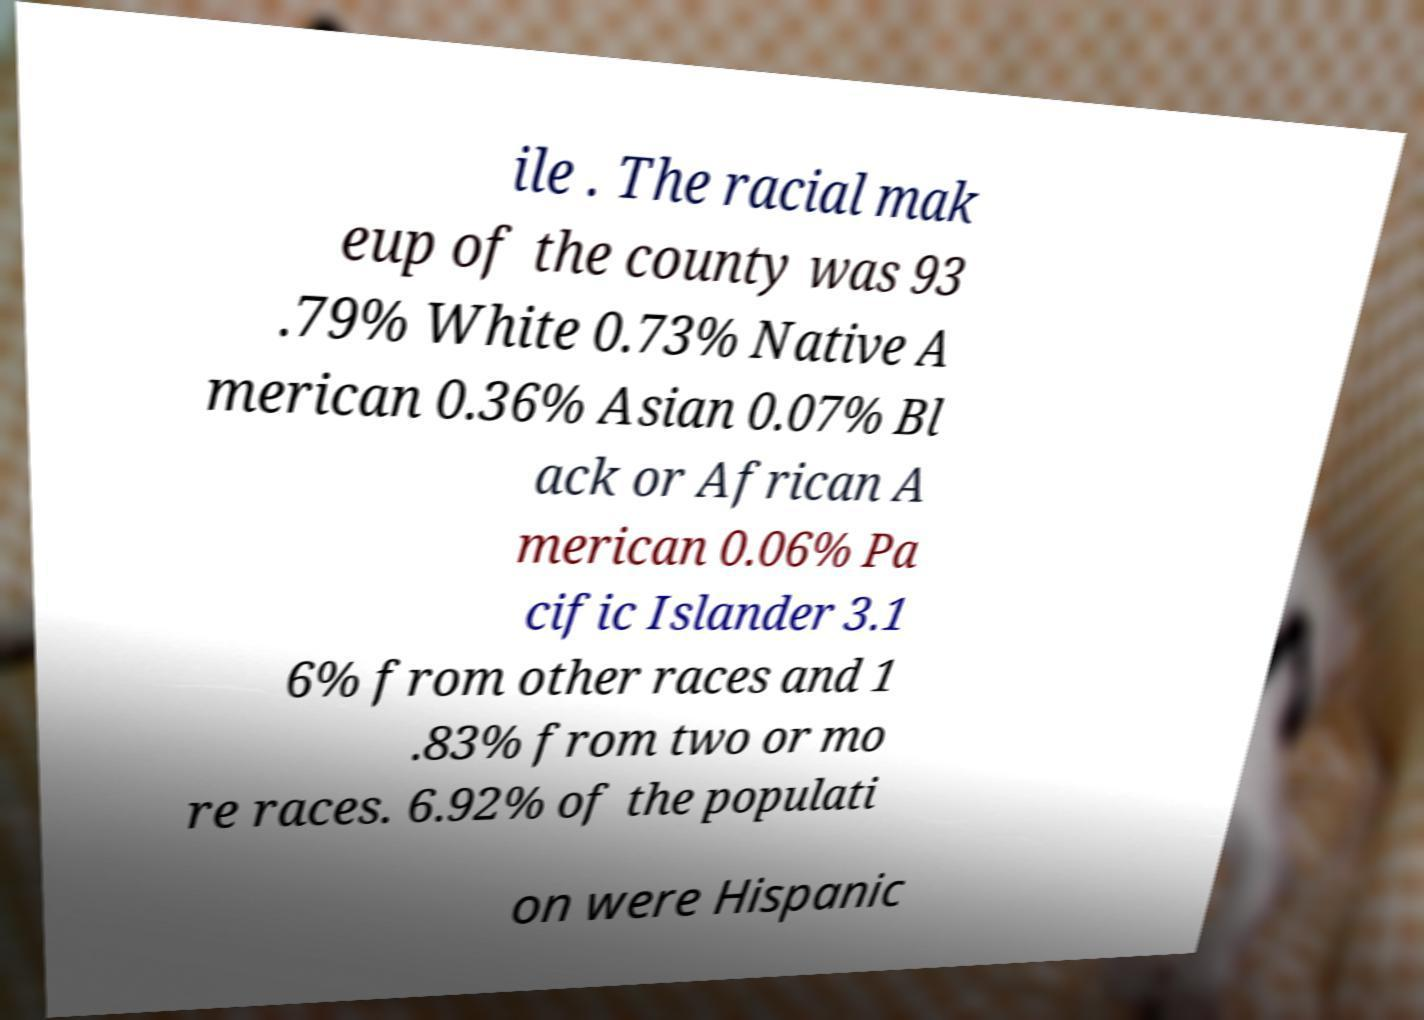Please read and relay the text visible in this image. What does it say? ile . The racial mak eup of the county was 93 .79% White 0.73% Native A merican 0.36% Asian 0.07% Bl ack or African A merican 0.06% Pa cific Islander 3.1 6% from other races and 1 .83% from two or mo re races. 6.92% of the populati on were Hispanic 